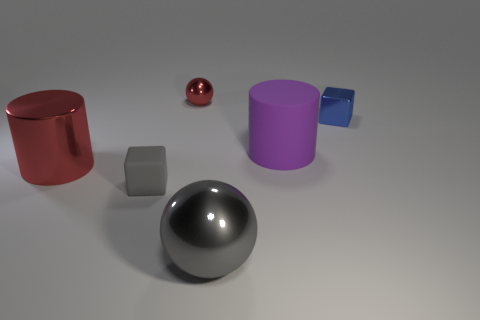Do the cylinder in front of the big purple object and the small shiny ball have the same color?
Keep it short and to the point. Yes. What material is the large ball that is the same color as the tiny rubber cube?
Make the answer very short. Metal. Is the color of the large thing in front of the matte block the same as the small block in front of the tiny metallic block?
Offer a very short reply. Yes. Are the gray thing that is to the right of the gray block and the tiny cube on the left side of the big gray thing made of the same material?
Ensure brevity in your answer.  No. The small block on the left side of the ball in front of the blue cube is made of what material?
Offer a terse response. Rubber. There is a metallic thing that is right of the ball that is in front of the rubber cylinder that is left of the blue metallic object; what shape is it?
Offer a very short reply. Cube. There is another big thing that is the same shape as the purple thing; what material is it?
Your response must be concise. Metal. How many gray cubes are there?
Your answer should be very brief. 1. There is a tiny shiny object that is right of the big rubber cylinder; what is its shape?
Offer a terse response. Cube. There is a small thing that is on the right side of the metallic ball to the right of the red thing behind the big matte cylinder; what color is it?
Ensure brevity in your answer.  Blue. 